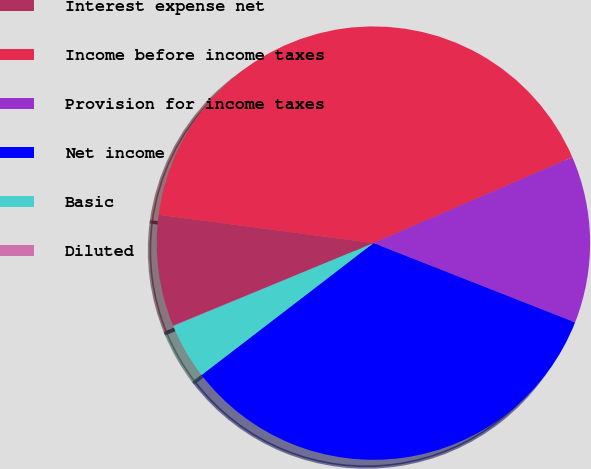Convert chart to OTSL. <chart><loc_0><loc_0><loc_500><loc_500><pie_chart><fcel>Interest expense net<fcel>Income before income taxes<fcel>Provision for income taxes<fcel>Net income<fcel>Basic<fcel>Diluted<nl><fcel>8.31%<fcel>41.43%<fcel>12.45%<fcel>33.62%<fcel>4.17%<fcel>0.03%<nl></chart> 